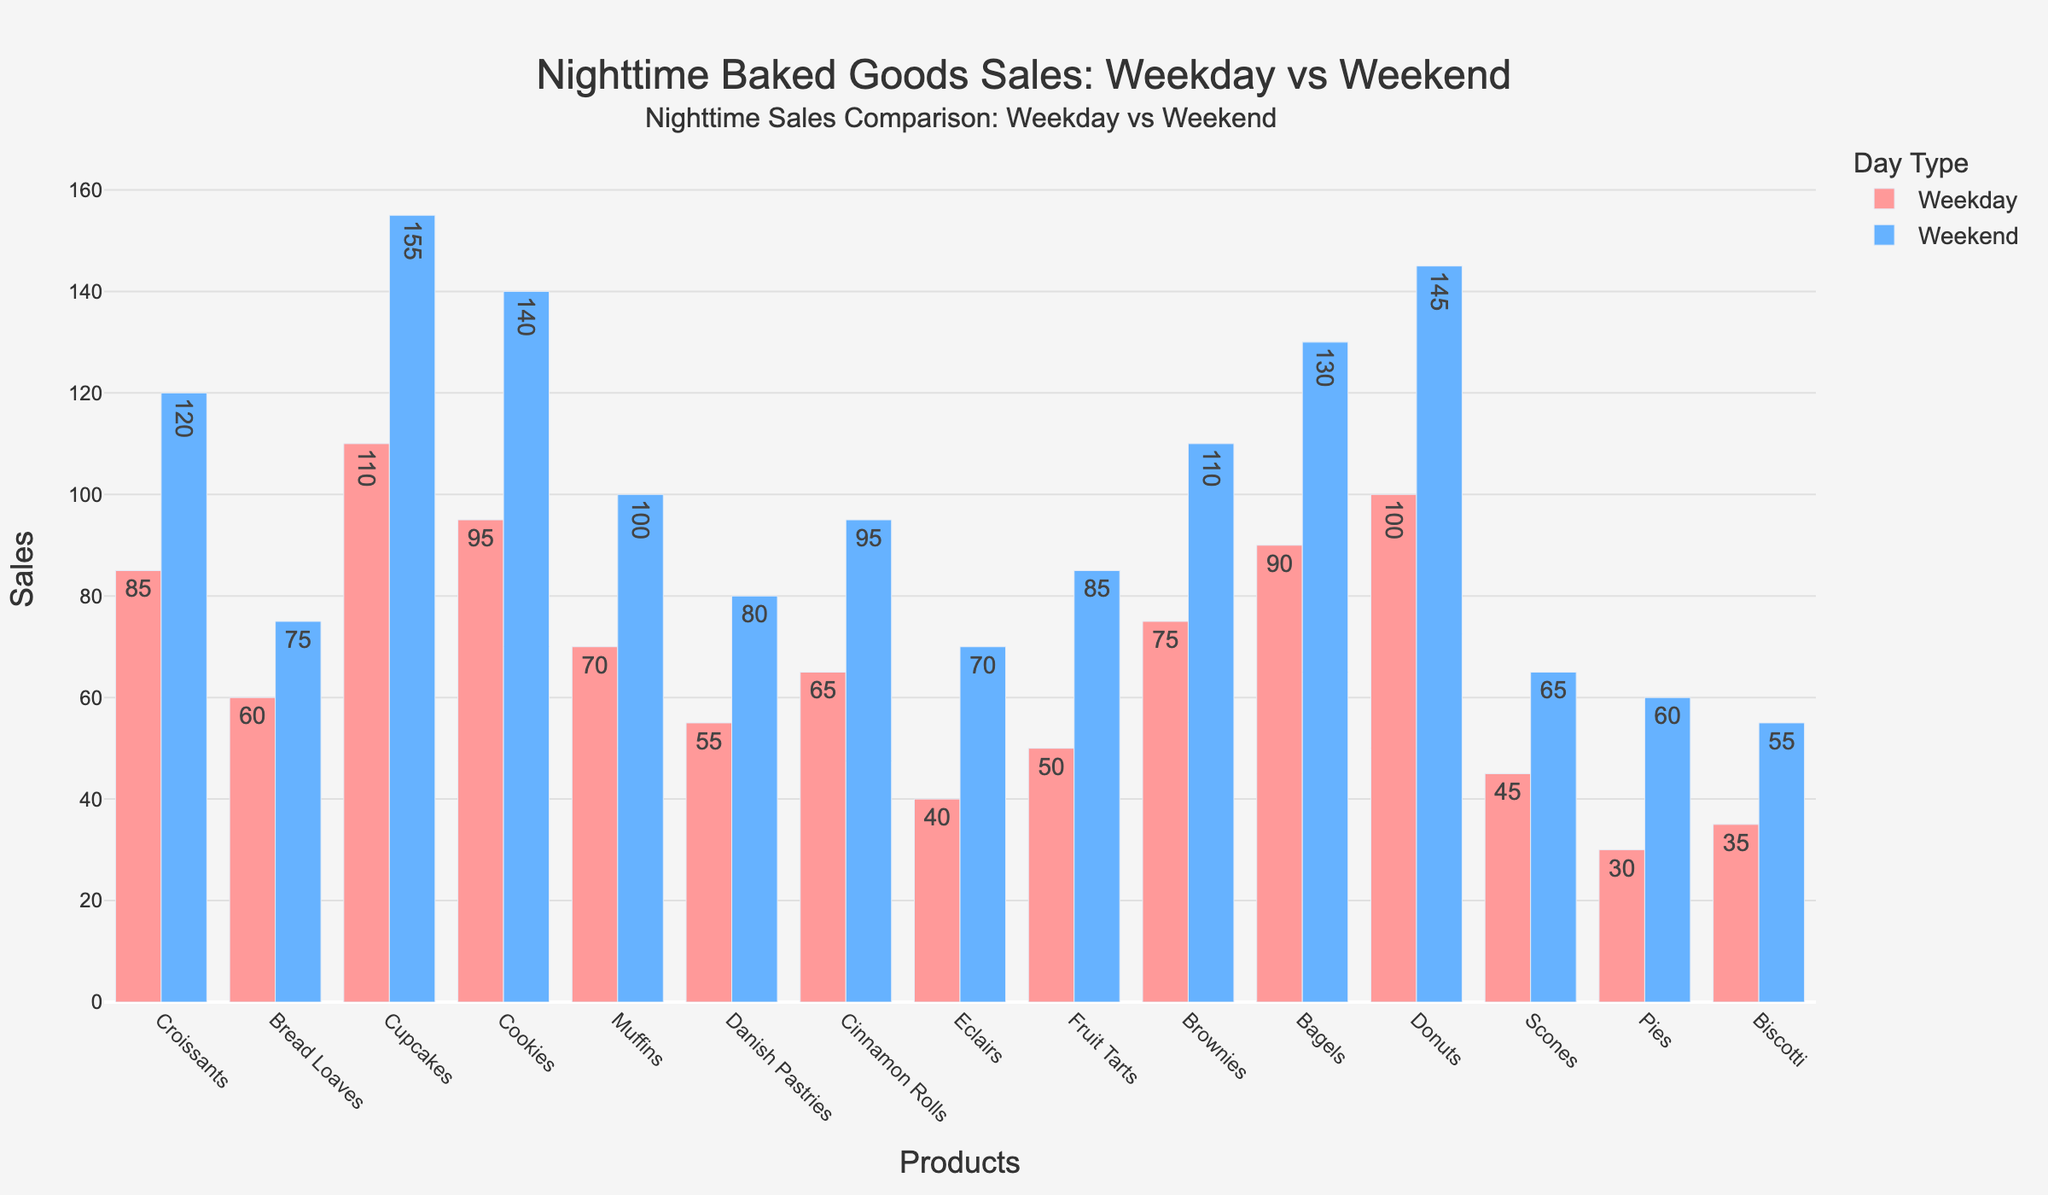Which product has the highest weekend nighttime sales? Look at the height of the bars representing weekend nighttime sales and identify the tallest one. Donuts have the highest weekend nighttime sales at 145 units.
Answer: Donuts Which two products have equal weekday nighttime sales? Compare the height of the bars representing weekday nighttime sales and find those with the same height. Muffins and Cinnamon Rolls both have weekday nighttime sales of 70 units.
Answer: Muffins and Cinnamon Rolls What is the difference in weekend nighttime sales between Cupcakes and Fruit Tarts? Subtract the weekend nighttime sales of Fruit Tarts from Cupcakes (155 - 85).
Answer: 70 Which product shows the greatest increase from weekday to weekend nighttime sales? Calculate the difference between weekend and weekday nighttime sales for each product and identify the highest. Cupcakes show the greatest increase from 110 to 155, which is 45 units.
Answer: Cupcakes What is the total weekend nighttime sales for Croissants and Donuts combined? Sum the weekend nighttime sales of Croissants and Donuts (120 + 145).
Answer: 265 On average, do products have higher nighttime sales on weekends or weekdays? Compare the average sales of all products on weekends and weekdays. The weekend average is higher. Calculate: (sum of weekend sales / number of products) compared to (sum of weekday sales / number of products).
Answer: Weekends Is there a product with higher weekday nighttime sales than weekend nighttime sales? Compare each product's weekday and weekend nighttime sales. No product has higher weekday nighttime sales than weekend nighttime sales.
Answer: No What is the ratio of weekend to weekday nighttime sales for Eclairs? Divide the weekend nighttime sales of Eclairs by the weekday nighttime sales (70 / 40).
Answer: 1.75 Which product has the smallest nighttime weekend sales increase compared to its weekday sales? Calculate the weekend - weekday sales for each product and find the smallest positive difference. Danish Pastries have the smallest increase (80 - 55 = 25).
Answer: Danish Pastries 